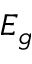Convert formula to latex. <formula><loc_0><loc_0><loc_500><loc_500>E _ { g }</formula> 